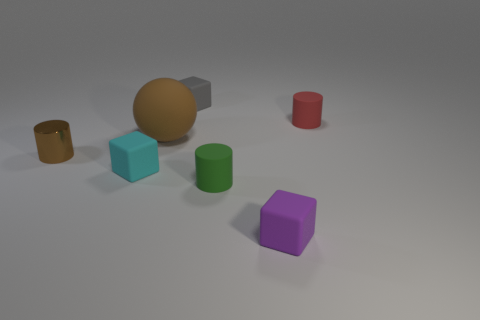Can you describe the lighting and shadows visible in this scene? The image displays a subtle and even lighting, casting gentle shadows to the right side of the objects, suggesting a light source to the left. The shadows are soft-edged, indicating the light source is not overly harsh and provides a calm and understated ambience. 